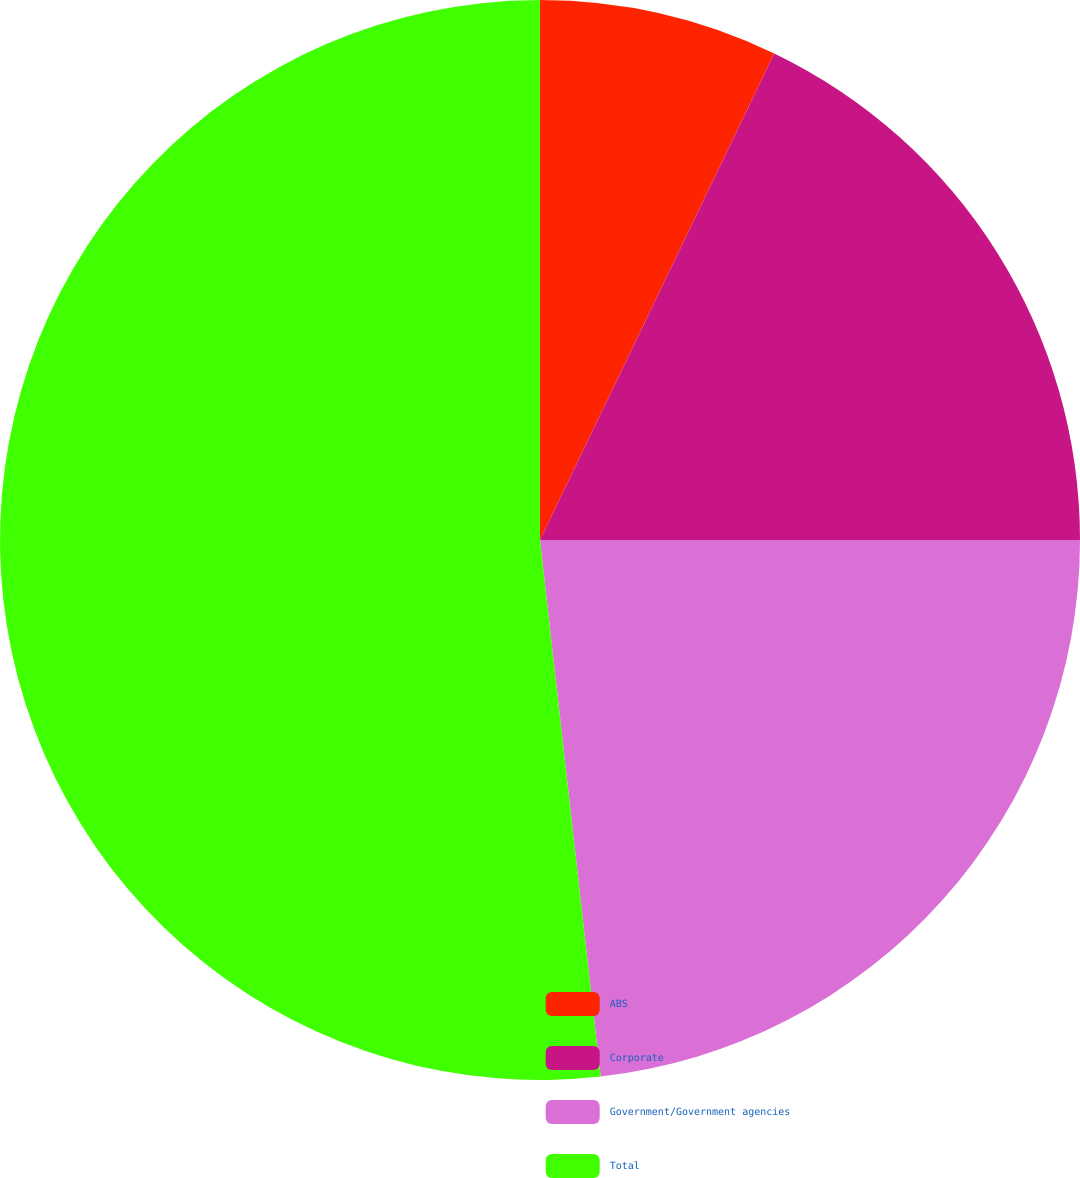Convert chart to OTSL. <chart><loc_0><loc_0><loc_500><loc_500><pie_chart><fcel>ABS<fcel>Corporate<fcel>Government/Government agencies<fcel>Total<nl><fcel>7.14%<fcel>17.86%<fcel>23.21%<fcel>51.79%<nl></chart> 